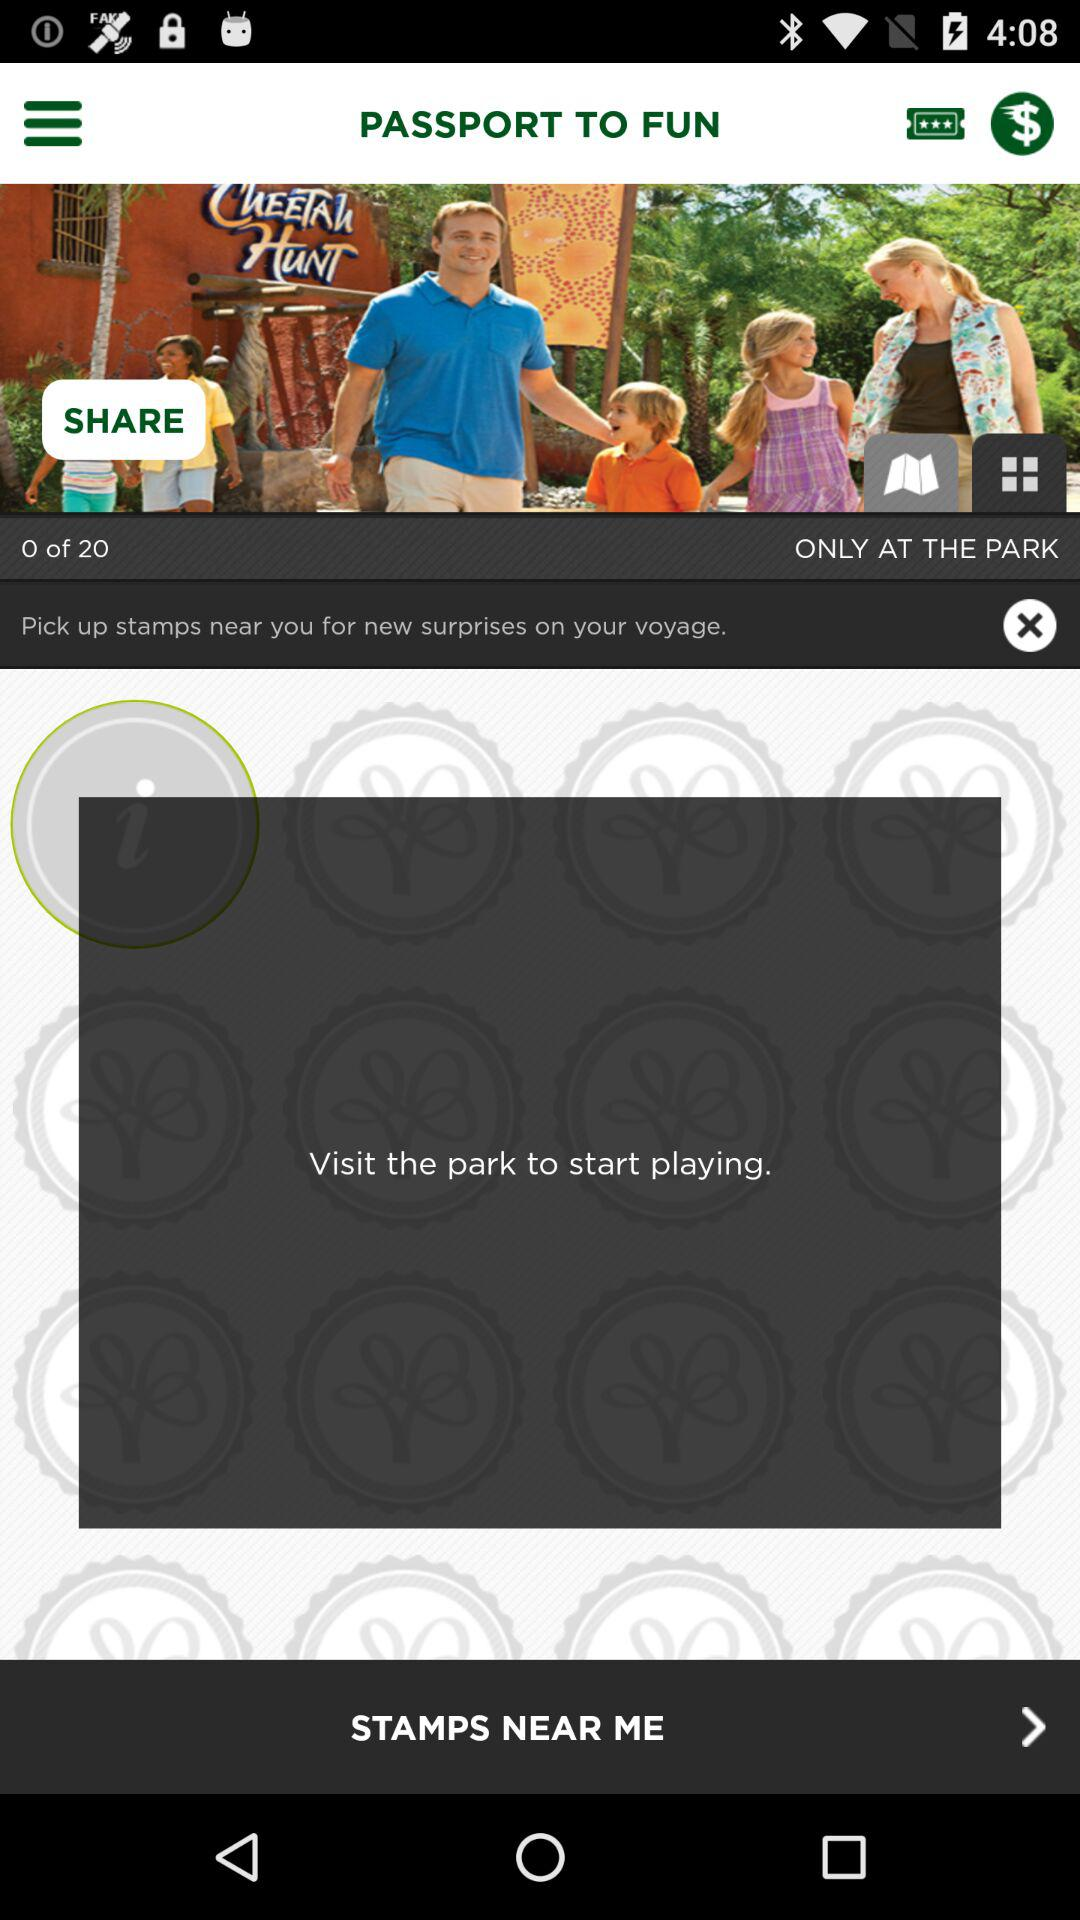How many stamps do I need to collect to get a new surprise?
Answer the question using a single word or phrase. 20 